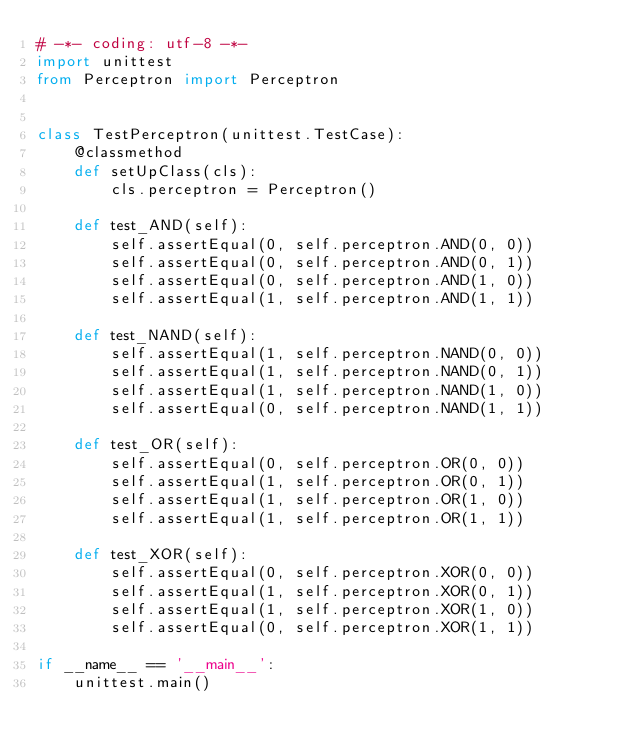Convert code to text. <code><loc_0><loc_0><loc_500><loc_500><_Python_># -*- coding: utf-8 -*-
import unittest
from Perceptron import Perceptron


class TestPerceptron(unittest.TestCase):
    @classmethod
    def setUpClass(cls):
        cls.perceptron = Perceptron()

    def test_AND(self):
        self.assertEqual(0, self.perceptron.AND(0, 0))
        self.assertEqual(0, self.perceptron.AND(0, 1))
        self.assertEqual(0, self.perceptron.AND(1, 0))
        self.assertEqual(1, self.perceptron.AND(1, 1))

    def test_NAND(self):
        self.assertEqual(1, self.perceptron.NAND(0, 0))
        self.assertEqual(1, self.perceptron.NAND(0, 1))
        self.assertEqual(1, self.perceptron.NAND(1, 0))
        self.assertEqual(0, self.perceptron.NAND(1, 1))

    def test_OR(self):
        self.assertEqual(0, self.perceptron.OR(0, 0))
        self.assertEqual(1, self.perceptron.OR(0, 1))
        self.assertEqual(1, self.perceptron.OR(1, 0))
        self.assertEqual(1, self.perceptron.OR(1, 1))

    def test_XOR(self):
        self.assertEqual(0, self.perceptron.XOR(0, 0))
        self.assertEqual(1, self.perceptron.XOR(0, 1))
        self.assertEqual(1, self.perceptron.XOR(1, 0))
        self.assertEqual(0, self.perceptron.XOR(1, 1))

if __name__ == '__main__':
    unittest.main()</code> 